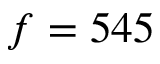Convert formula to latex. <formula><loc_0><loc_0><loc_500><loc_500>f = 5 4 5</formula> 